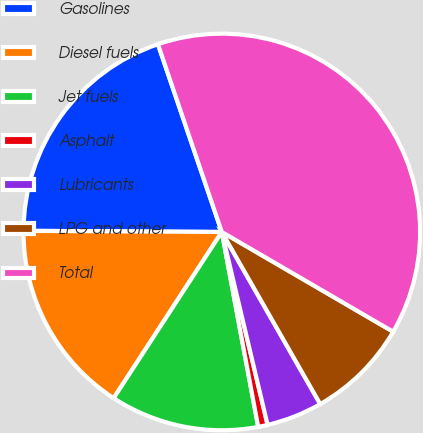Convert chart to OTSL. <chart><loc_0><loc_0><loc_500><loc_500><pie_chart><fcel>Gasolines<fcel>Diesel fuels<fcel>Jet fuels<fcel>Asphalt<fcel>Lubricants<fcel>LPG and other<fcel>Total<nl><fcel>19.69%<fcel>15.91%<fcel>12.12%<fcel>0.77%<fcel>4.56%<fcel>8.34%<fcel>38.61%<nl></chart> 